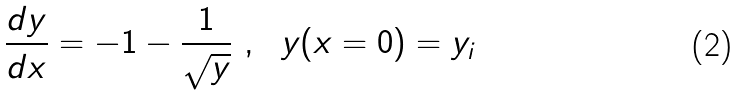<formula> <loc_0><loc_0><loc_500><loc_500>\frac { d y } { d x } = - 1 - \frac { 1 } { \sqrt { y } } \ , \ \ y ( x = 0 ) = y _ { i }</formula> 